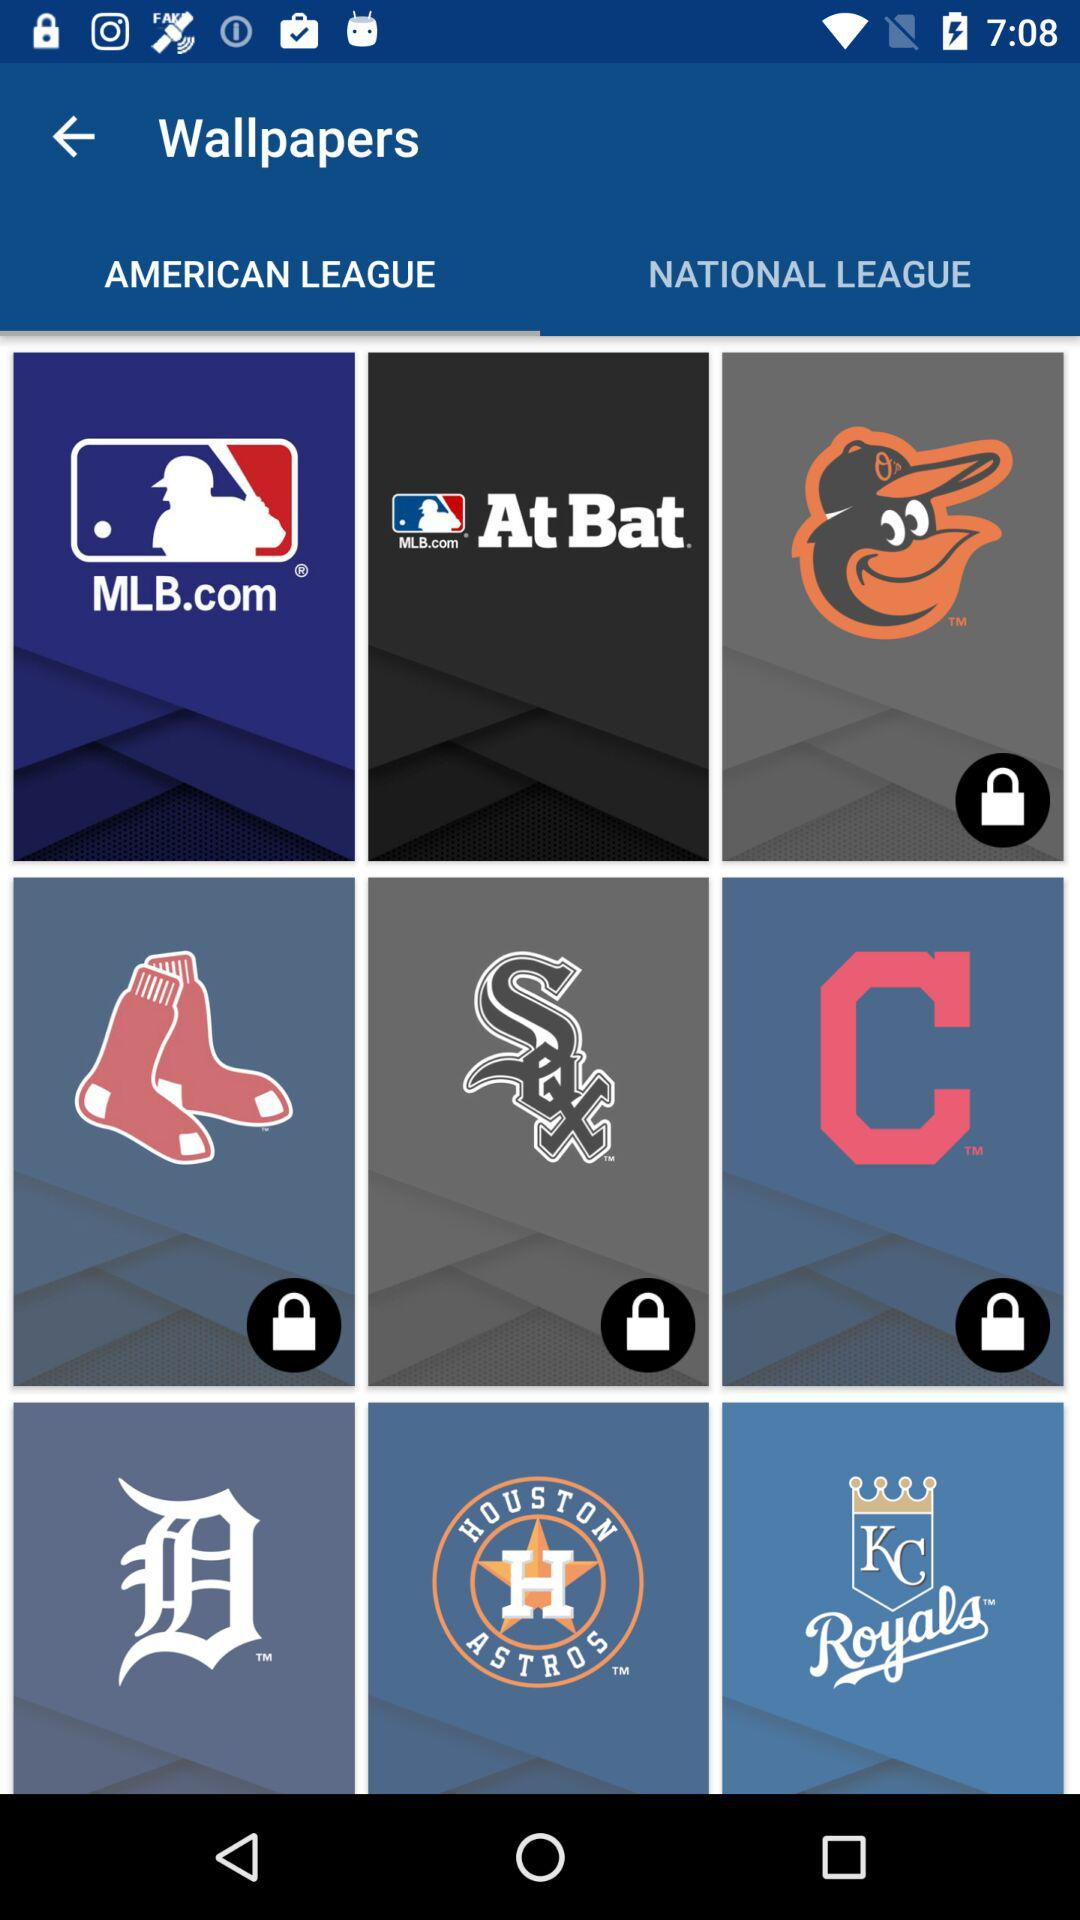What is the name of the application? The name of the application is "Wallpapers". 